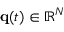<formula> <loc_0><loc_0><loc_500><loc_500>{ q } ( t ) \in \mathbb { R } ^ { N }</formula> 